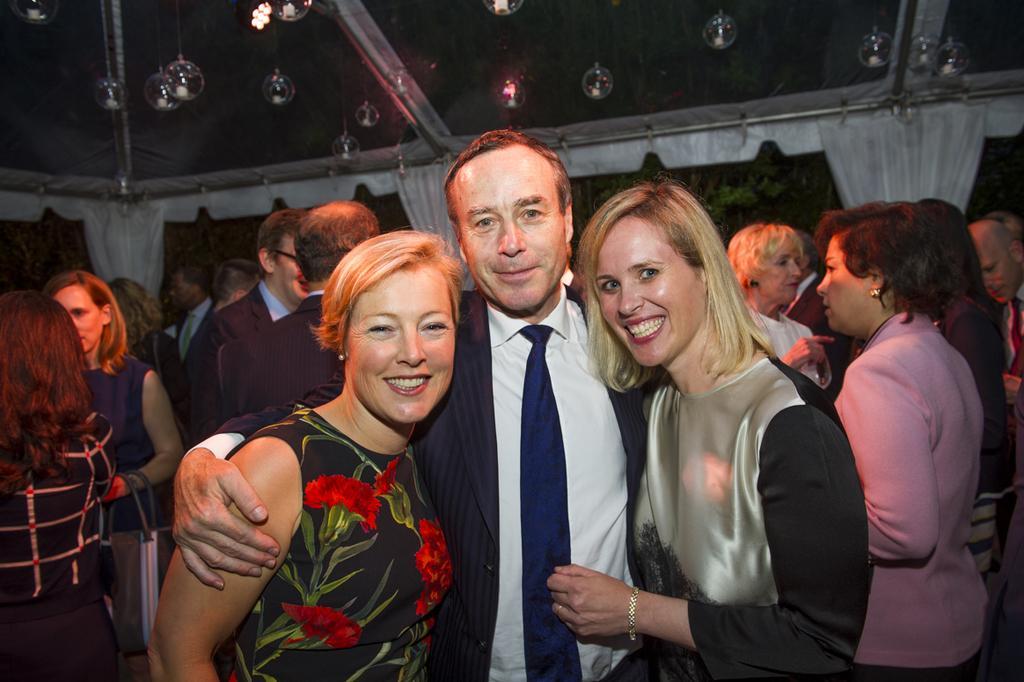Can you describe this image briefly? As we can see in the image there are group of people, wall, white color curtains and bubbles. 